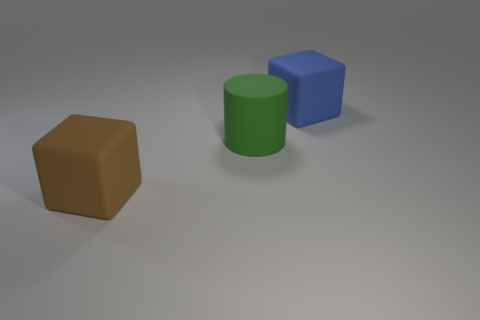The green thing that is to the right of the brown rubber thing has what shape?
Provide a succinct answer. Cylinder. Are there any other things that are the same shape as the large green thing?
Your answer should be very brief. No. Are any metallic spheres visible?
Offer a terse response. No. What material is the thing that is in front of the large blue rubber thing and on the right side of the brown thing?
Your response must be concise. Rubber. What number of big brown objects are behind the blue cube?
Your answer should be very brief. 0. What is the color of the cylinder that is the same material as the big blue cube?
Your answer should be compact. Green. Does the large blue rubber object have the same shape as the large brown thing?
Give a very brief answer. Yes. What number of things are both right of the brown rubber block and left of the blue rubber object?
Provide a short and direct response. 1. How many shiny objects are either large green things or blocks?
Keep it short and to the point. 0. There is a matte block that is in front of the large matte block on the right side of the big brown rubber thing; how big is it?
Ensure brevity in your answer.  Large. 